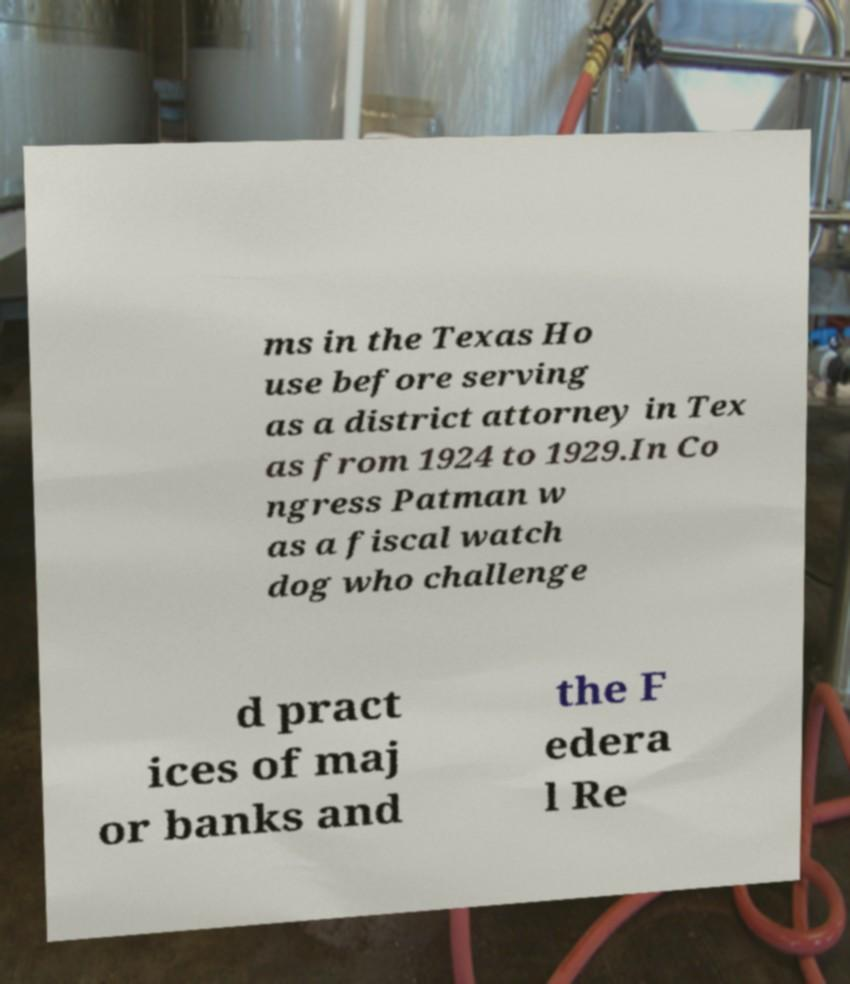There's text embedded in this image that I need extracted. Can you transcribe it verbatim? ms in the Texas Ho use before serving as a district attorney in Tex as from 1924 to 1929.In Co ngress Patman w as a fiscal watch dog who challenge d pract ices of maj or banks and the F edera l Re 